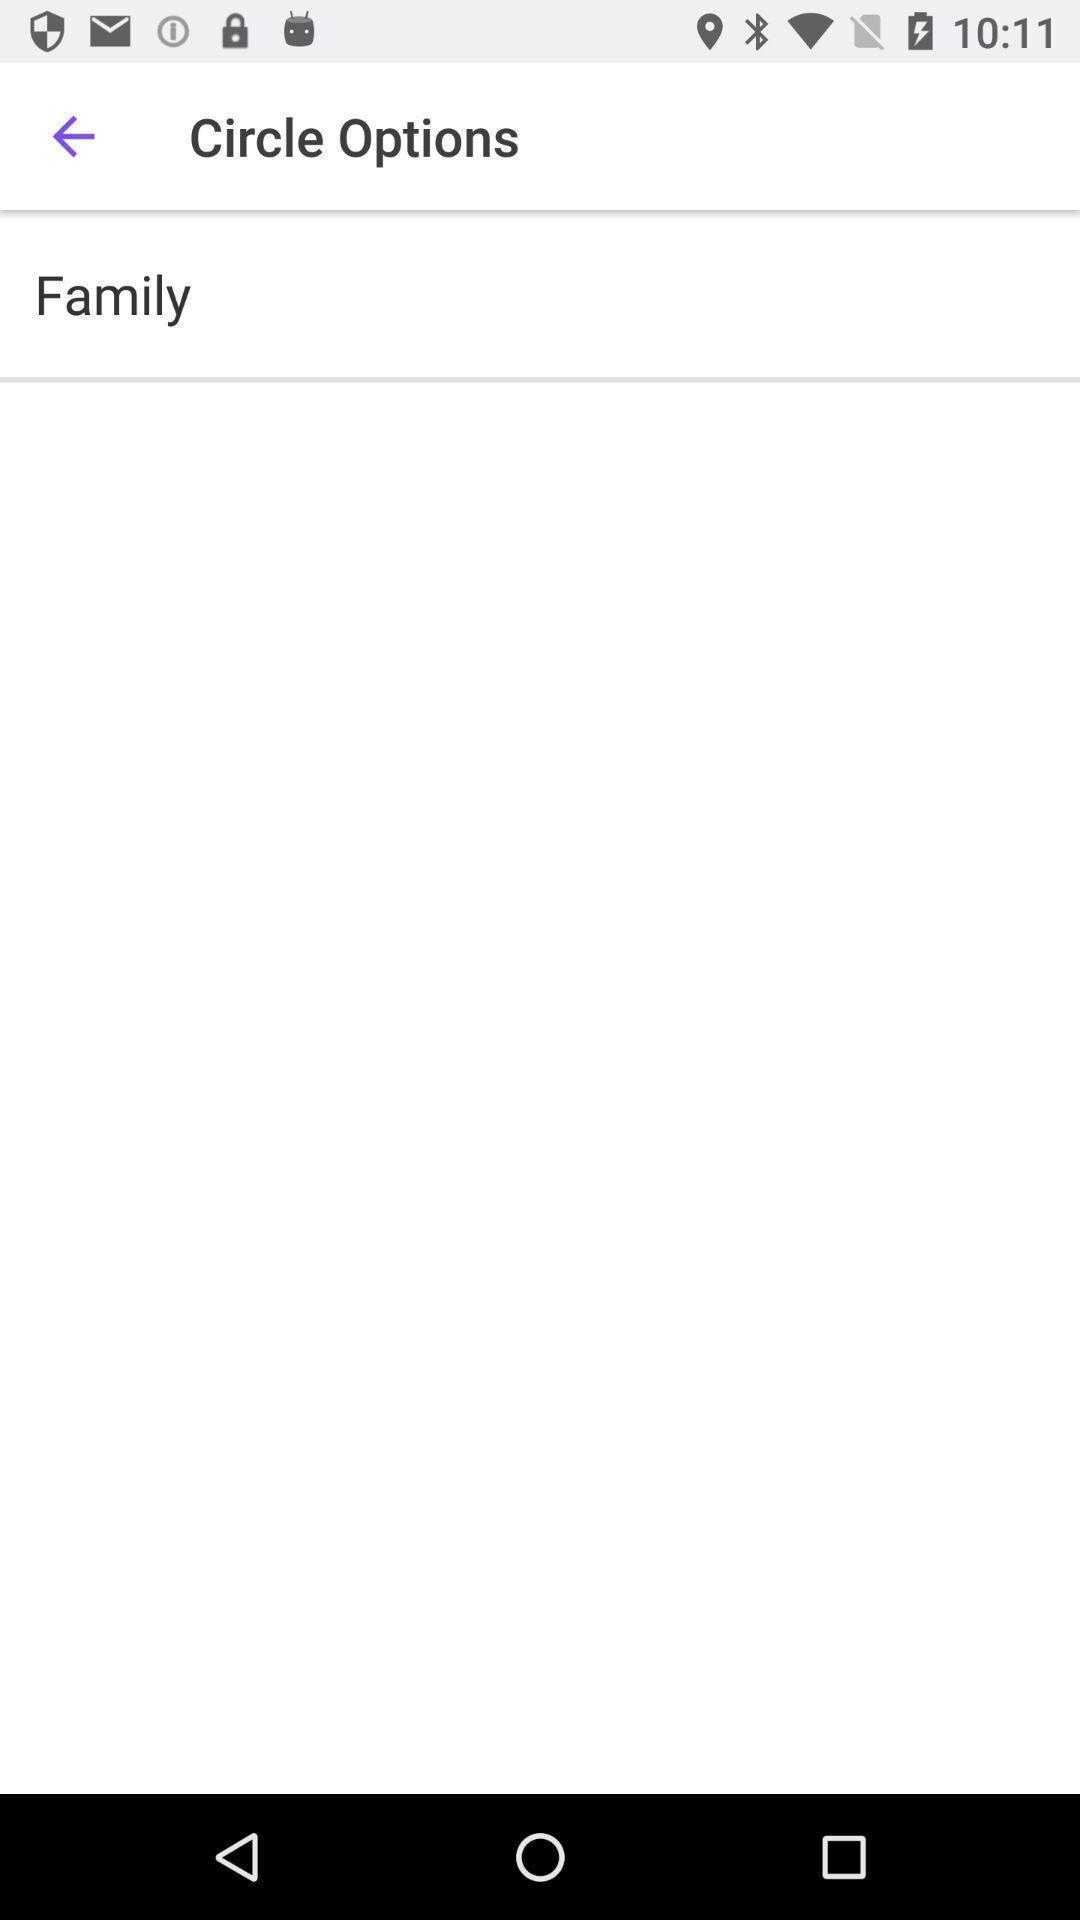Describe this image in words. Page shows about a family circle details. 